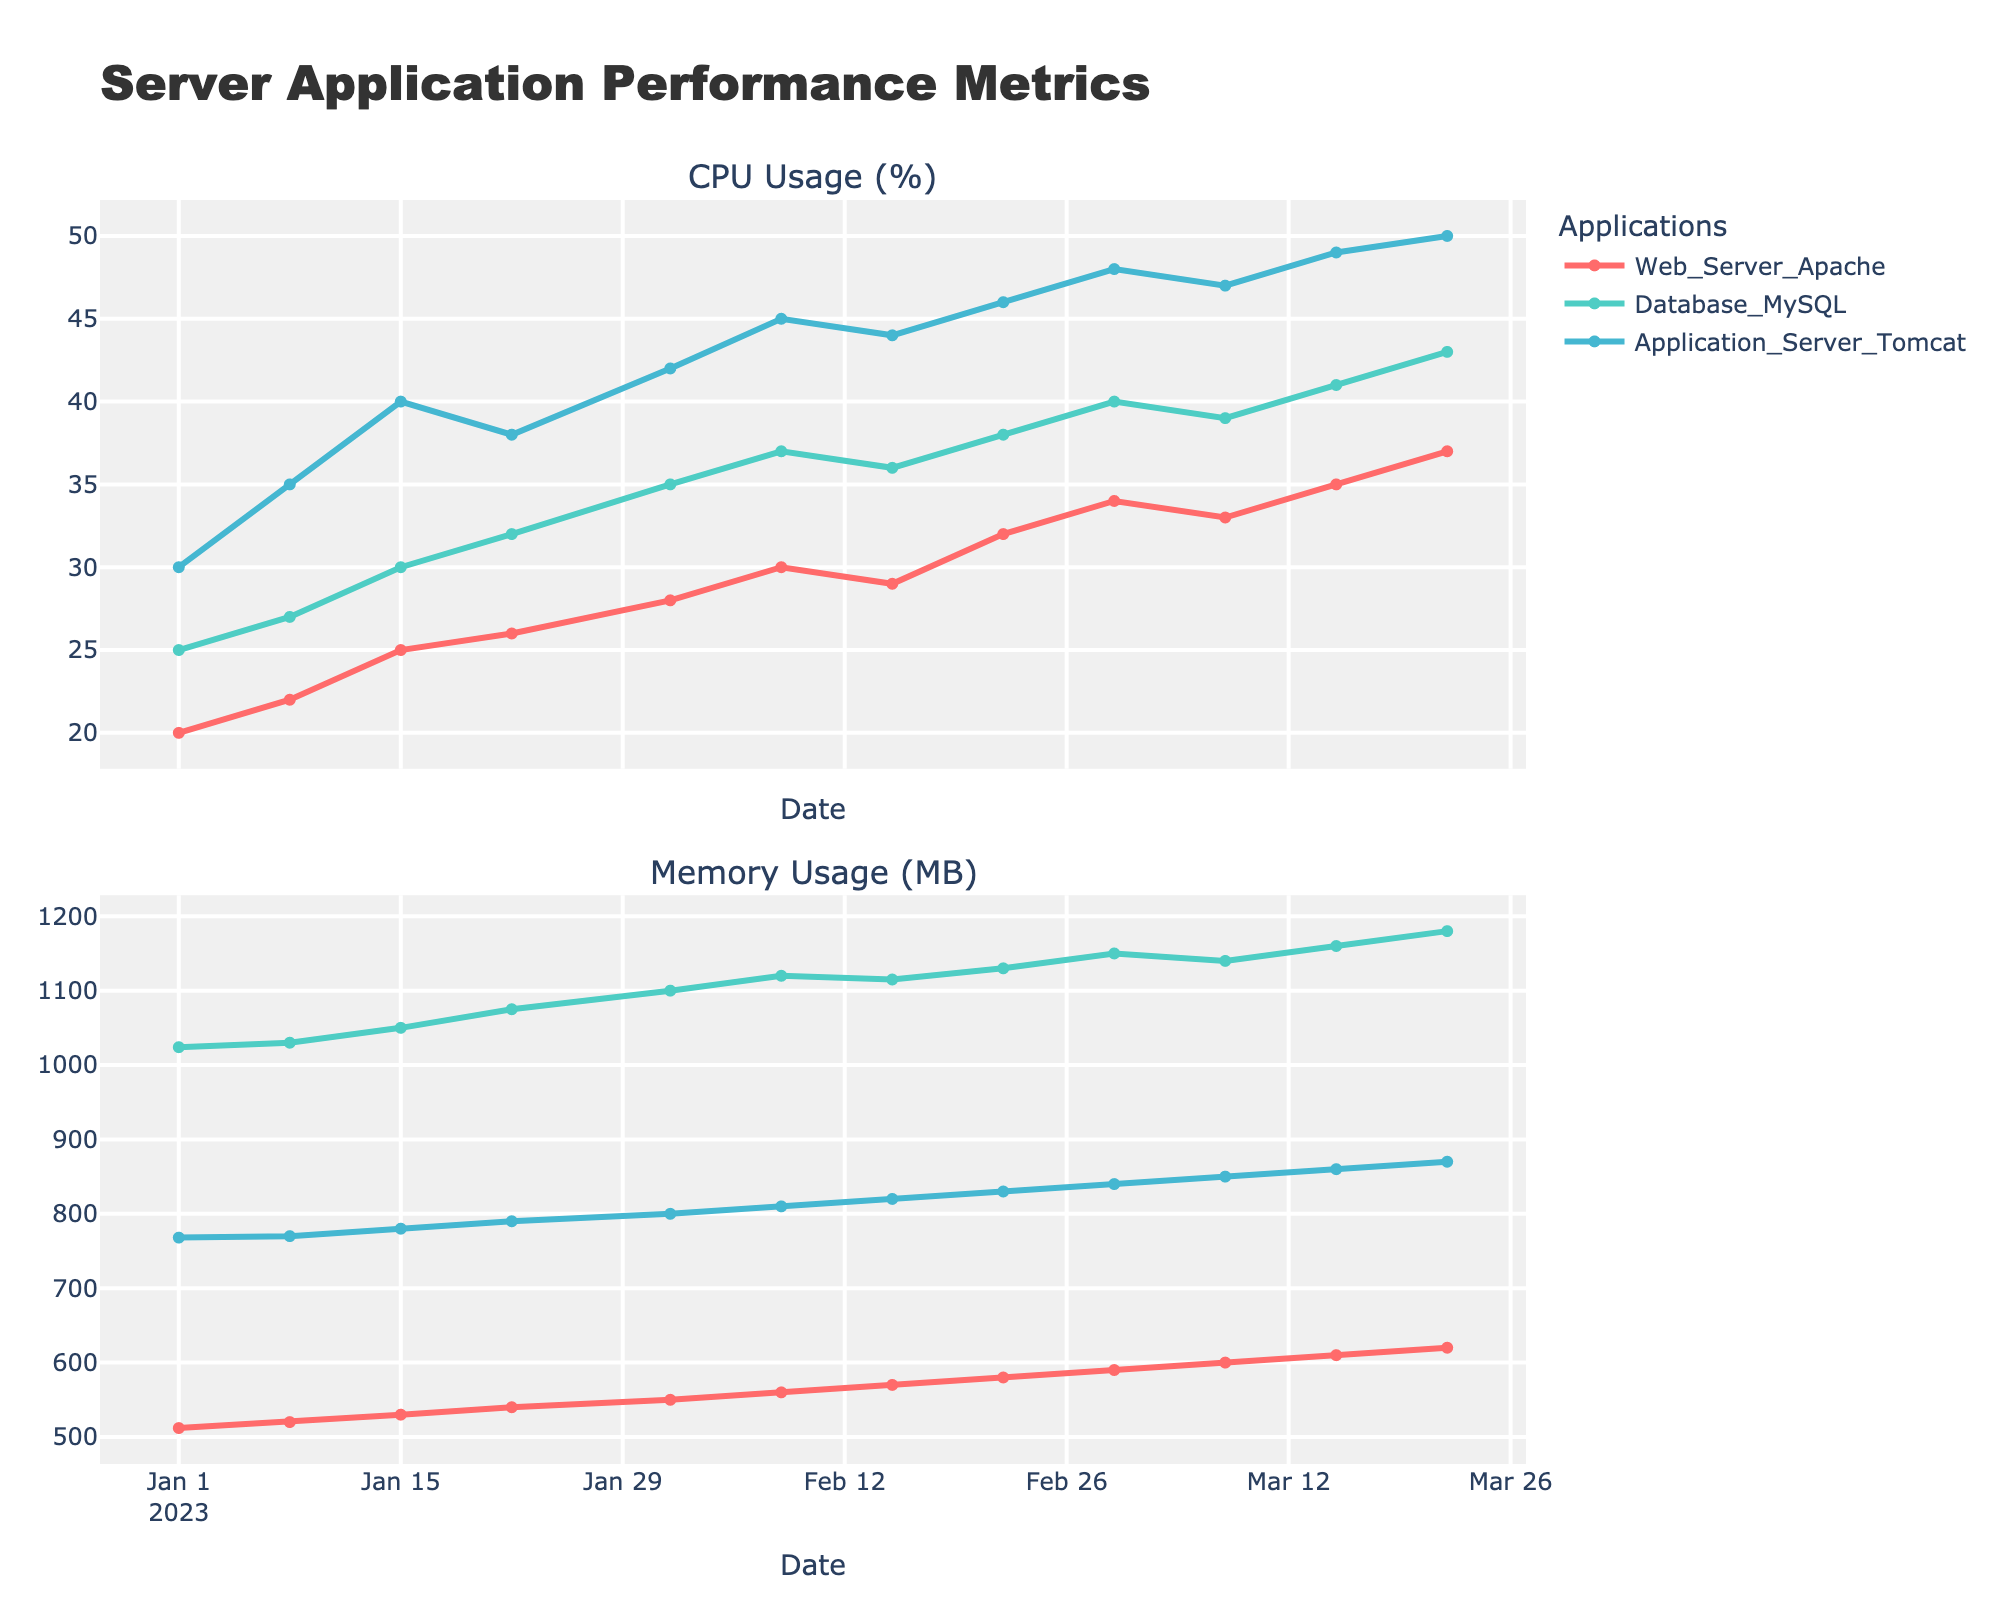What is the title of the plot? The title of the plot is displayed at the top of the figure. It's intended to give a quick summary of what the plot is about. Here, from the given settings, it's "Server Application Performance Metrics."
Answer: Server Application Performance Metrics Which application had the highest CPU usage on March 22, 2023? To find the highest CPU usage on March 22, 2023, look at the top subplot for this date and compare the values of CPU usage for different applications. "Application_Server_Tomcat" shows a peak at 50%.
Answer: Application_Server_Tomcat What were the CPU and memory usage for Database_MySQL on February 15, 2023? To find these values, check the data point for Database_MySQL on February 15, 2023. In the CPU usage subplot, Database_MySQL's value is 36%, and in the Memory usage subplot, it's 1115 MB.
Answer: 36%, 1115 MB How does the CPU usage of Web_Server_Apache on January 1, 2023, compare to February 1, 2023? First, identify the CPU usage values for Web_Server_Apache on January 1, 2023, and February 1, 2023. They are 20% and 28%, respectively. Comparatively, the CPU usage increased from January to February by 8 percentage points.
Answer: Increased by 8% Which application had the steepest rise in memory usage over the entire period? To determine which application had the steepest rise, inspect the slope of the lines in the bottom subplot for each application across the dates. "Application_Server_Tomcat" shows the steepest upward trend in memory usage starting from 768 MB to 870 MB.
Answer: Application_Server_Tomcat On which date did Web_Server_Apache's CPU usage first surpass 30%? Look at the top subplot and trace Web_Server_Apache's line, marked in a distinct color, to find when it first goes beyond 30%. This occurs on March 1, 2023.
Answer: March 1, 2023 Calculate the average memory usage of Database_MySQL over the quarter. To find the average memory usage, sum all the memory usage values for Database_MySQL and then divide by the number of data points. The values are (1024 + 1030 + 1050 + 1075 + 1100 + 1120 + 1115 + 1130 + 1150 + 1140 + 1160 + 1180). Their total is 13674. Dividing by 12 (total data points) gives 1139.5 MB.
Answer: 1139.5 MB How did the memory usage of Application_Server_Tomcat change between January 8, 2023, and January 15, 2023? To observe the change in memory usage, compare the values on January 8, 2023, (770 MB) and January 15, 2023, (780 MB). The increase is 10 MB.
Answer: Increased by 10 MB Which application shows the least fluctuation in CPU usage throughout the quarter? To determine the application with the most consistent CPU usage, inspect the top subplot for the smoothest line. "Web_Server_Apache" exhibits the least fluctuation with minor variations between 20% and 37%.
Answer: Web_Server_Apache 